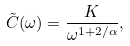Convert formula to latex. <formula><loc_0><loc_0><loc_500><loc_500>\tilde { C } ( \omega ) = \frac { K } { \omega ^ { 1 + 2 / \alpha } } ,</formula> 